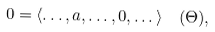Convert formula to latex. <formula><loc_0><loc_0><loc_500><loc_500>0 = \langle \dots , a , \dots , 0 , \dots \rangle \pod { \Theta } ,</formula> 